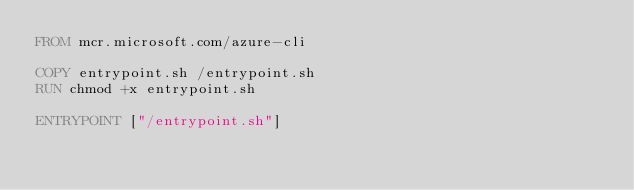<code> <loc_0><loc_0><loc_500><loc_500><_Dockerfile_>FROM mcr.microsoft.com/azure-cli

COPY entrypoint.sh /entrypoint.sh
RUN chmod +x entrypoint.sh

ENTRYPOINT ["/entrypoint.sh"]
</code> 